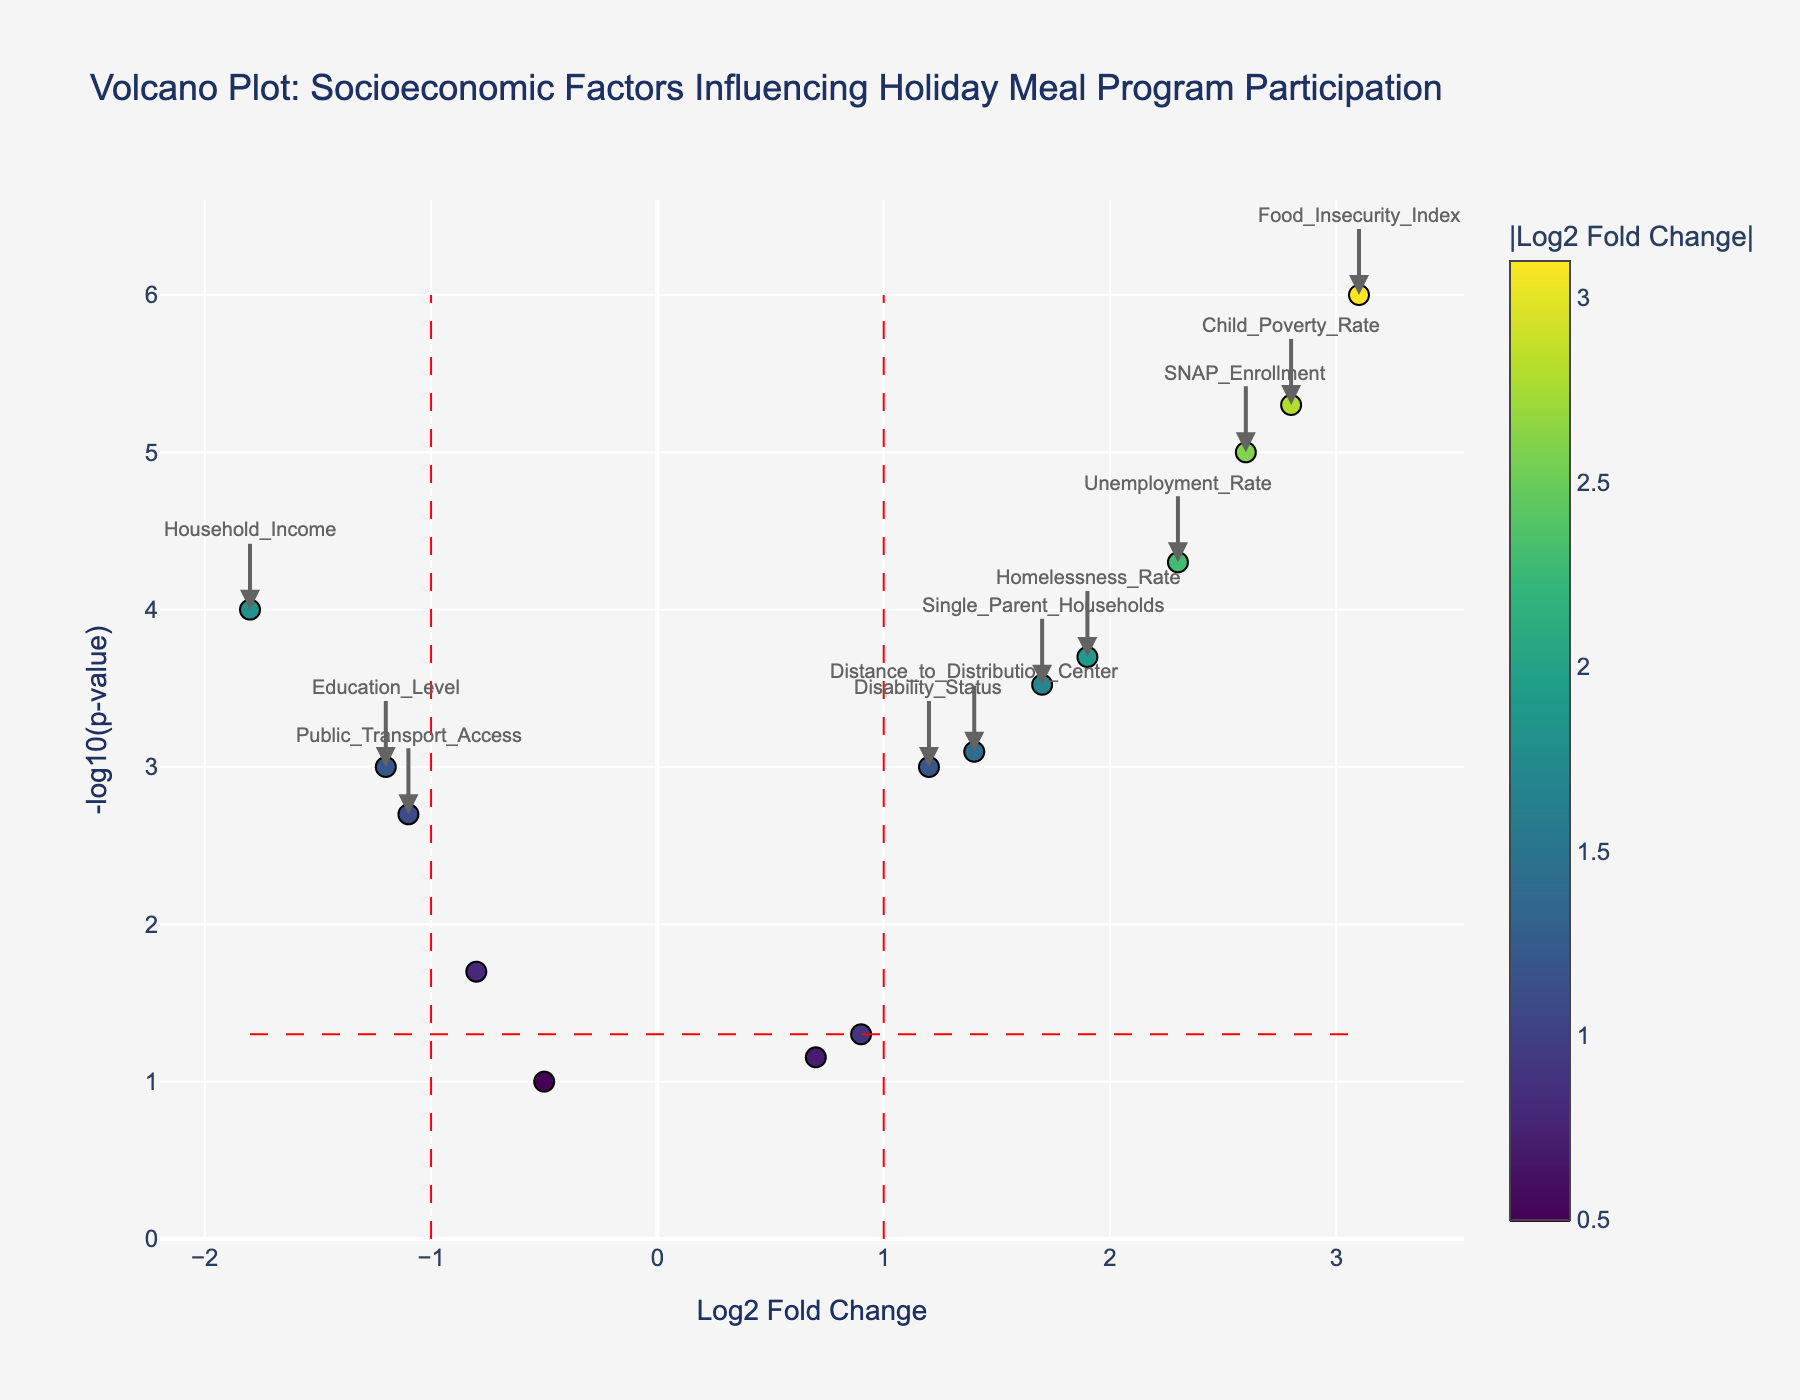Which feature has the highest -log10(p-value) value? Look for the feature with the highest y-value on the plot, which represents the highest -log10(p-value). The highest point corresponds to the "Food_Insecurity_Index".
Answer: Food_Insecurity_Index How many features have a log2 fold change greater than 1? Identify all points that are to the right of the vertical red line at x=1. There are 7 such features: Unemployment_Rate, Food_Insecurity_Index, Single_Parent_Households, Distance_to_Distribution_Center, SNAP_Enrollment, Homelessness_Rate, and Child_Poverty_Rate.
Answer: 7 Which feature shows the most significant decrease in participation rates? Look for the feature with the lowest log2 fold change on the plot. The point with the most negative x-value is "Household_Income" with a log2 fold change of -1.8.
Answer: Household_Income What is the log2 fold change and p-value for Food_Insecurity_Index? Find the point labeled "Food_Insecurity_Index" and refer to the hover text for detailed numbers. The log2 fold change is 3.1, and the p-value is approximately 1e-06.
Answer: Log2 Fold Change: 3.1, P-value: 1e-06 Which features are statistically significant (p-value < 0.05) and have a log2 fold change less than -1? Look for points below the horizontal red line at -log10(p-value) = -log10(0.05) and left of the vertical red line at x = -1. The features that meet these criteria are "Household_Income", "Education_Level", and "Public_Transport_Access".
Answer: Household_Income, Education_Level, Public_Transport_Access What is the significance threshold for p-value indicated on the plot? The significance threshold for p-value is represented by the horizontal red line, which is at -log10(0.05). The value of -log10(0.05) is approximately 1.3.
Answer: 1.3 Compare the log2 fold change of SNAP_Enrollment and Food_Insecurity_Index. Which is higher? Check the x-coordinates of SNAP_Enrollment and Food_Insecurity_Index. The log2 fold change for SNAP_Enrollment is 2.6, while for Food_Insecurity_Index, it is 3.1. Since 3.1 is greater than 2.6, the log2 fold change of Food_Insecurity_Index is higher.
Answer: Food_Insecurity_Index How many features have statistically significant results (p-value < 0.05)? Count the number of points below the horizontal red line at -log10(p-value) = -log10(0.05). There are 11 features below this line: Household_Income, Unemployment_Rate, Food_Insecurity_Index, Education_Level, Single_Parent_Households, Public_Transport_Access, Distance_to_Distribution_Center, SNAP_Enrollment, Homelessness_Rate, Disability_Status, and Child_Poverty_Rate.
Answer: 11 Which feature has the lowest -log10(p-value) value and is thus the least statistically significant? Identify the feature with the lowest y-value on the plot. The feature "Veteran_Status" has the lowest -log10(p-value) of approximately 1.
Answer: Veteran_Status 